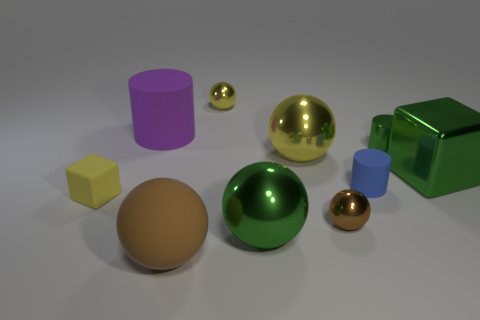What is the shape of the yellow shiny object that is the same size as the blue rubber object?
Make the answer very short. Sphere. Are there any green blocks behind the large green cube?
Offer a very short reply. No. Do the rubber block and the shiny block have the same size?
Make the answer very short. No. What is the shape of the small rubber thing on the right side of the rubber block?
Your response must be concise. Cylinder. Are there any matte objects that have the same size as the blue rubber cylinder?
Your answer should be very brief. Yes. There is a cylinder that is the same size as the metallic cube; what is it made of?
Offer a terse response. Rubber. There is a green shiny object behind the shiny block; what is its size?
Provide a succinct answer. Small. The purple thing has what size?
Offer a very short reply. Large. There is a shiny cylinder; is it the same size as the green shiny object that is in front of the small blue rubber thing?
Ensure brevity in your answer.  No. What is the color of the tiny sphere that is behind the green shiny object behind the big metal cube?
Make the answer very short. Yellow. 